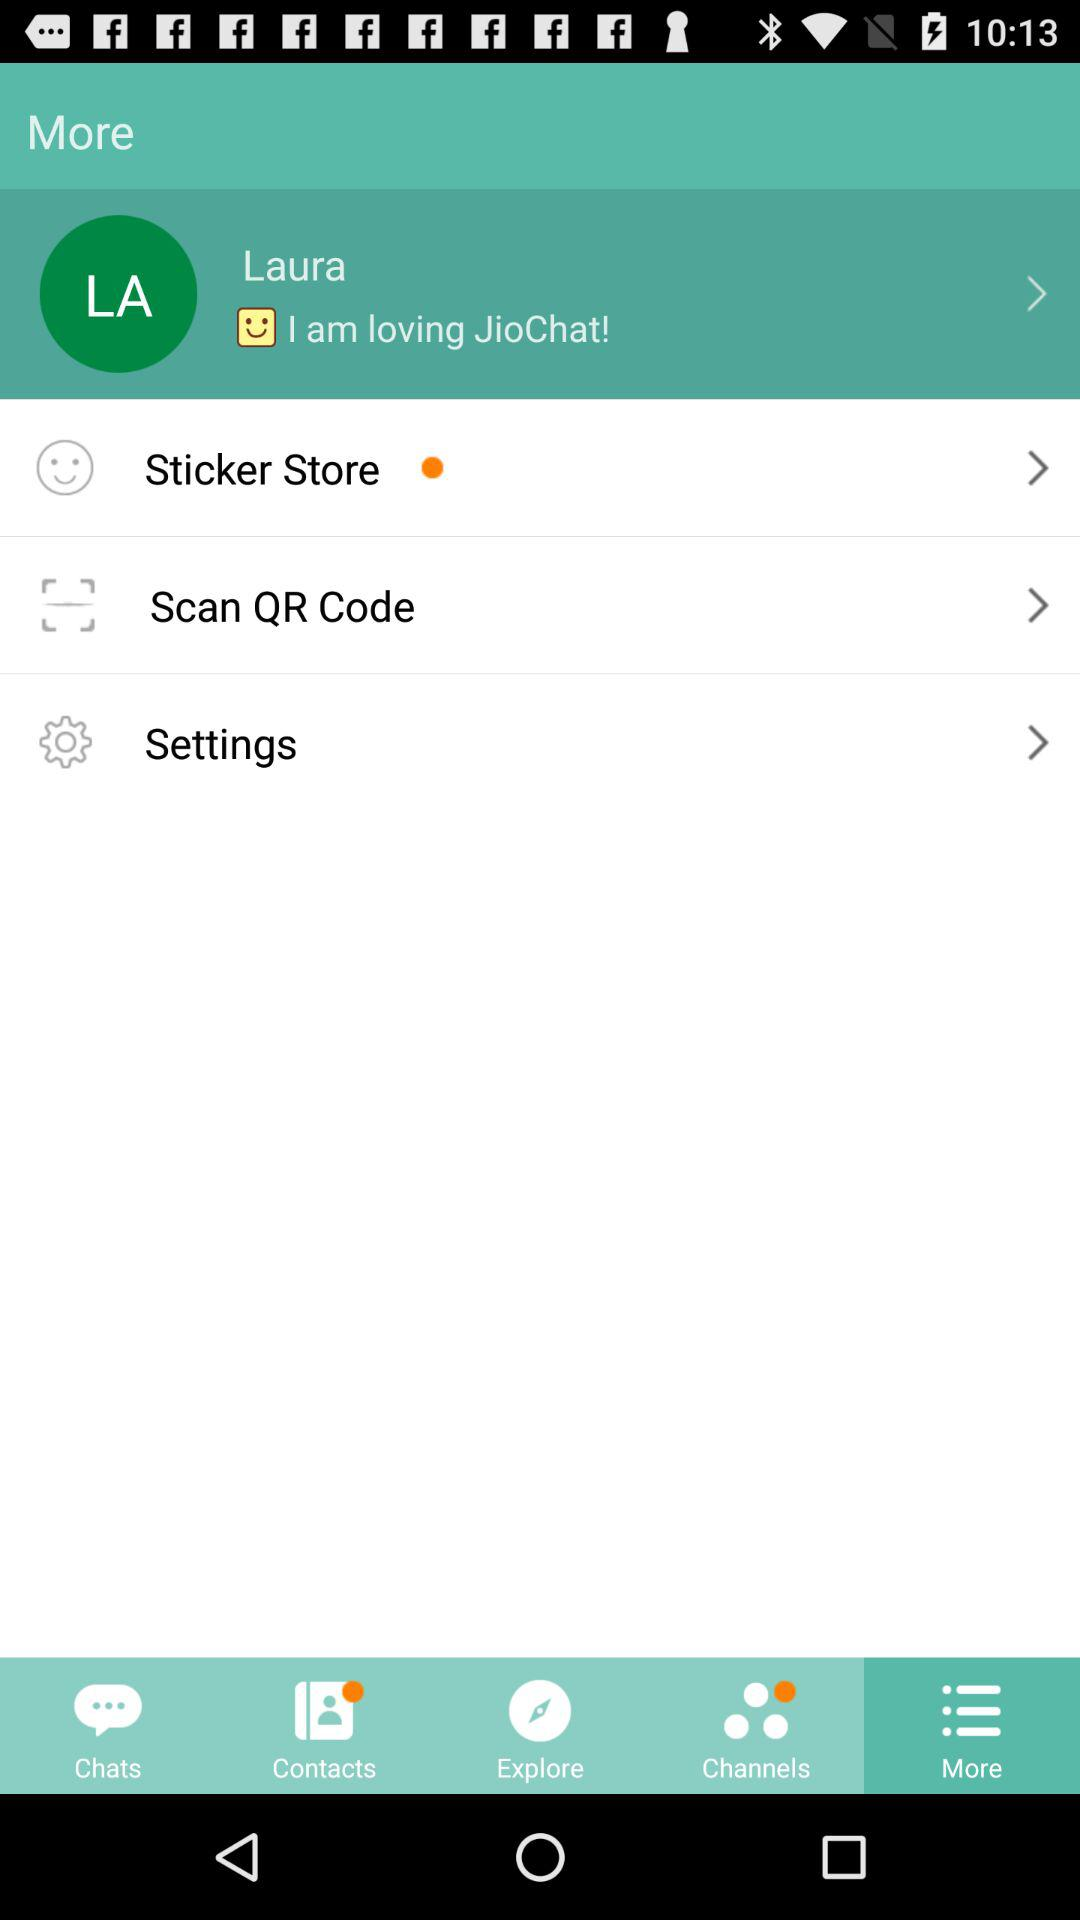Which tab has been selected? The tab "More" has been selected. 